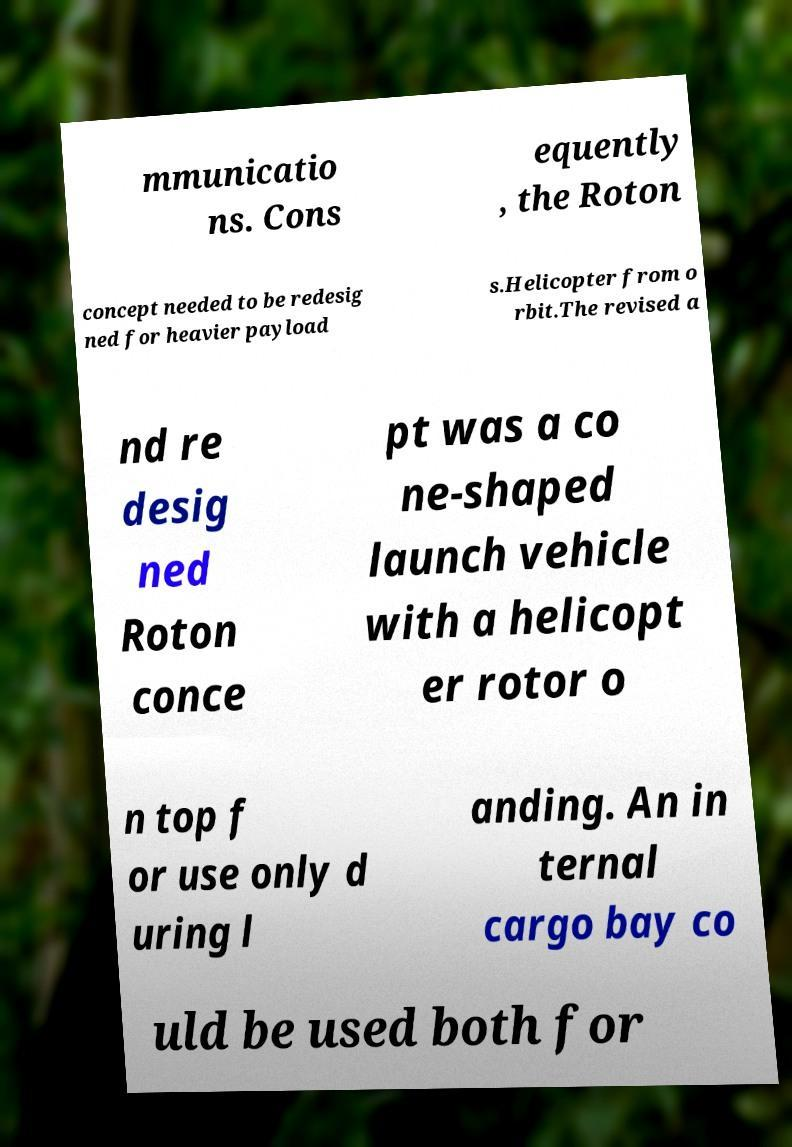Please read and relay the text visible in this image. What does it say? mmunicatio ns. Cons equently , the Roton concept needed to be redesig ned for heavier payload s.Helicopter from o rbit.The revised a nd re desig ned Roton conce pt was a co ne-shaped launch vehicle with a helicopt er rotor o n top f or use only d uring l anding. An in ternal cargo bay co uld be used both for 